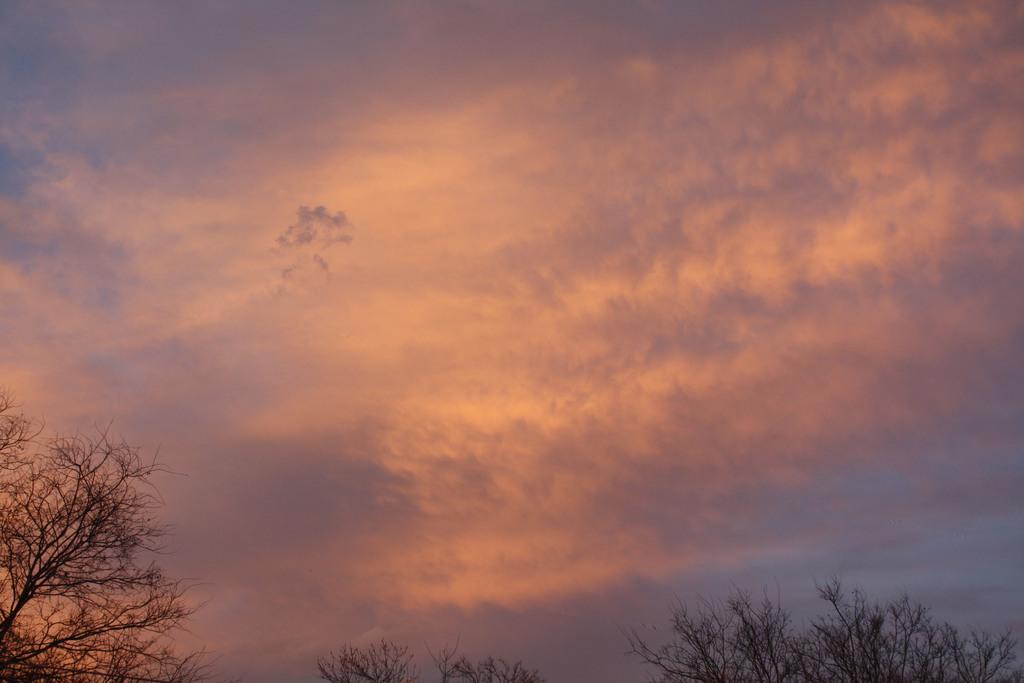Describe this image in one or two sentences. In the image in the center, we can see the sky, clouds and trees. 